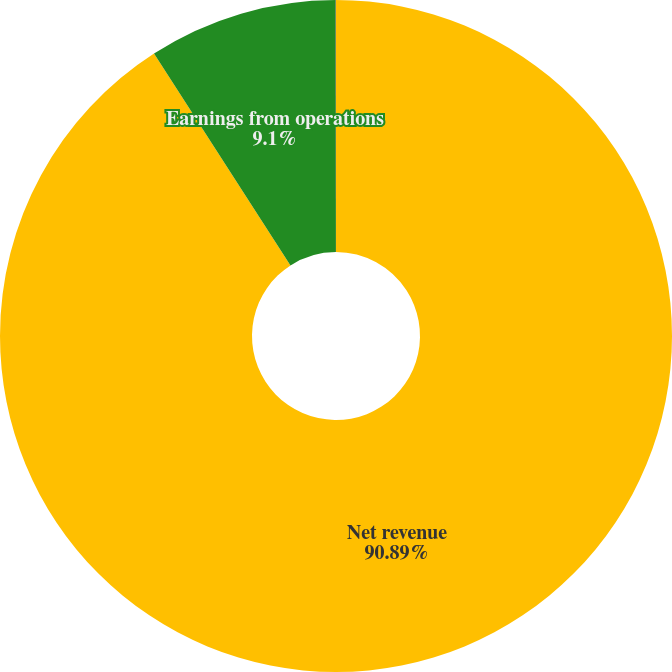<chart> <loc_0><loc_0><loc_500><loc_500><pie_chart><fcel>Net revenue<fcel>Earnings from operations<fcel>Earnings from operations as a<nl><fcel>90.89%<fcel>9.1%<fcel>0.01%<nl></chart> 